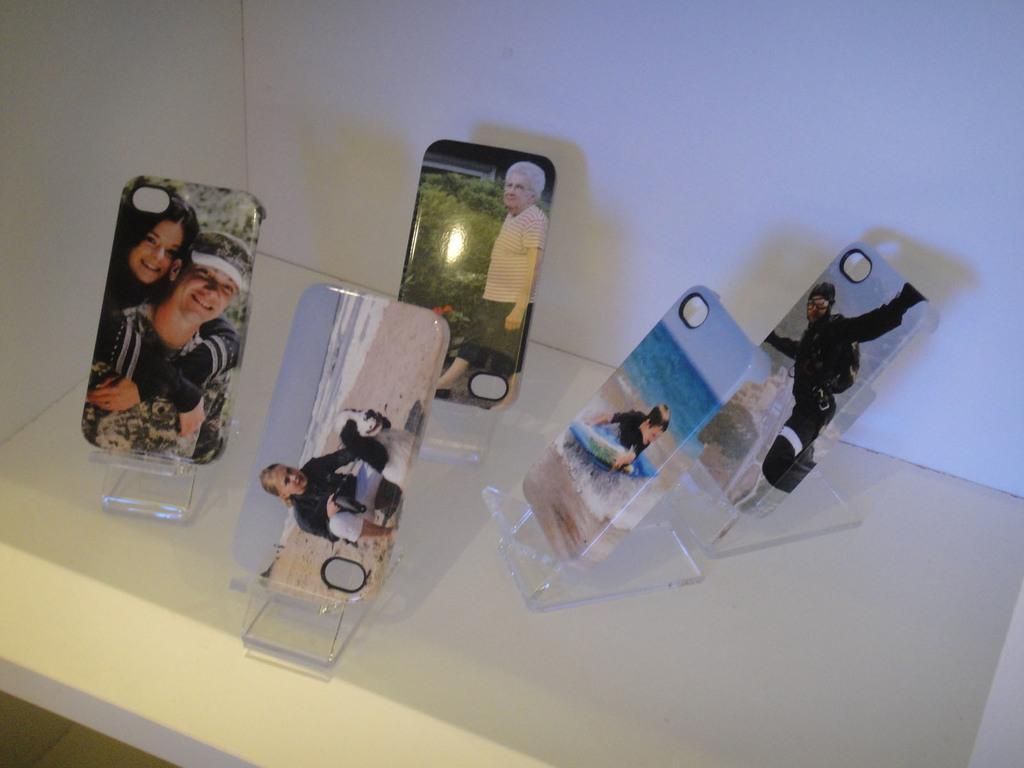Please provide a concise description of this image. In this picture we can see mobile back cases with stands on the white platform. We can see wall. 